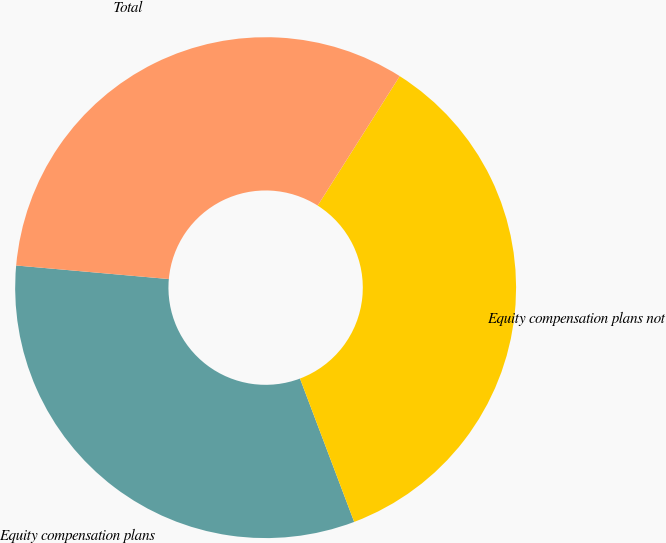<chart> <loc_0><loc_0><loc_500><loc_500><pie_chart><fcel>Equity compensation plans<fcel>Equity compensation plans not<fcel>Total<nl><fcel>32.16%<fcel>35.25%<fcel>32.58%<nl></chart> 